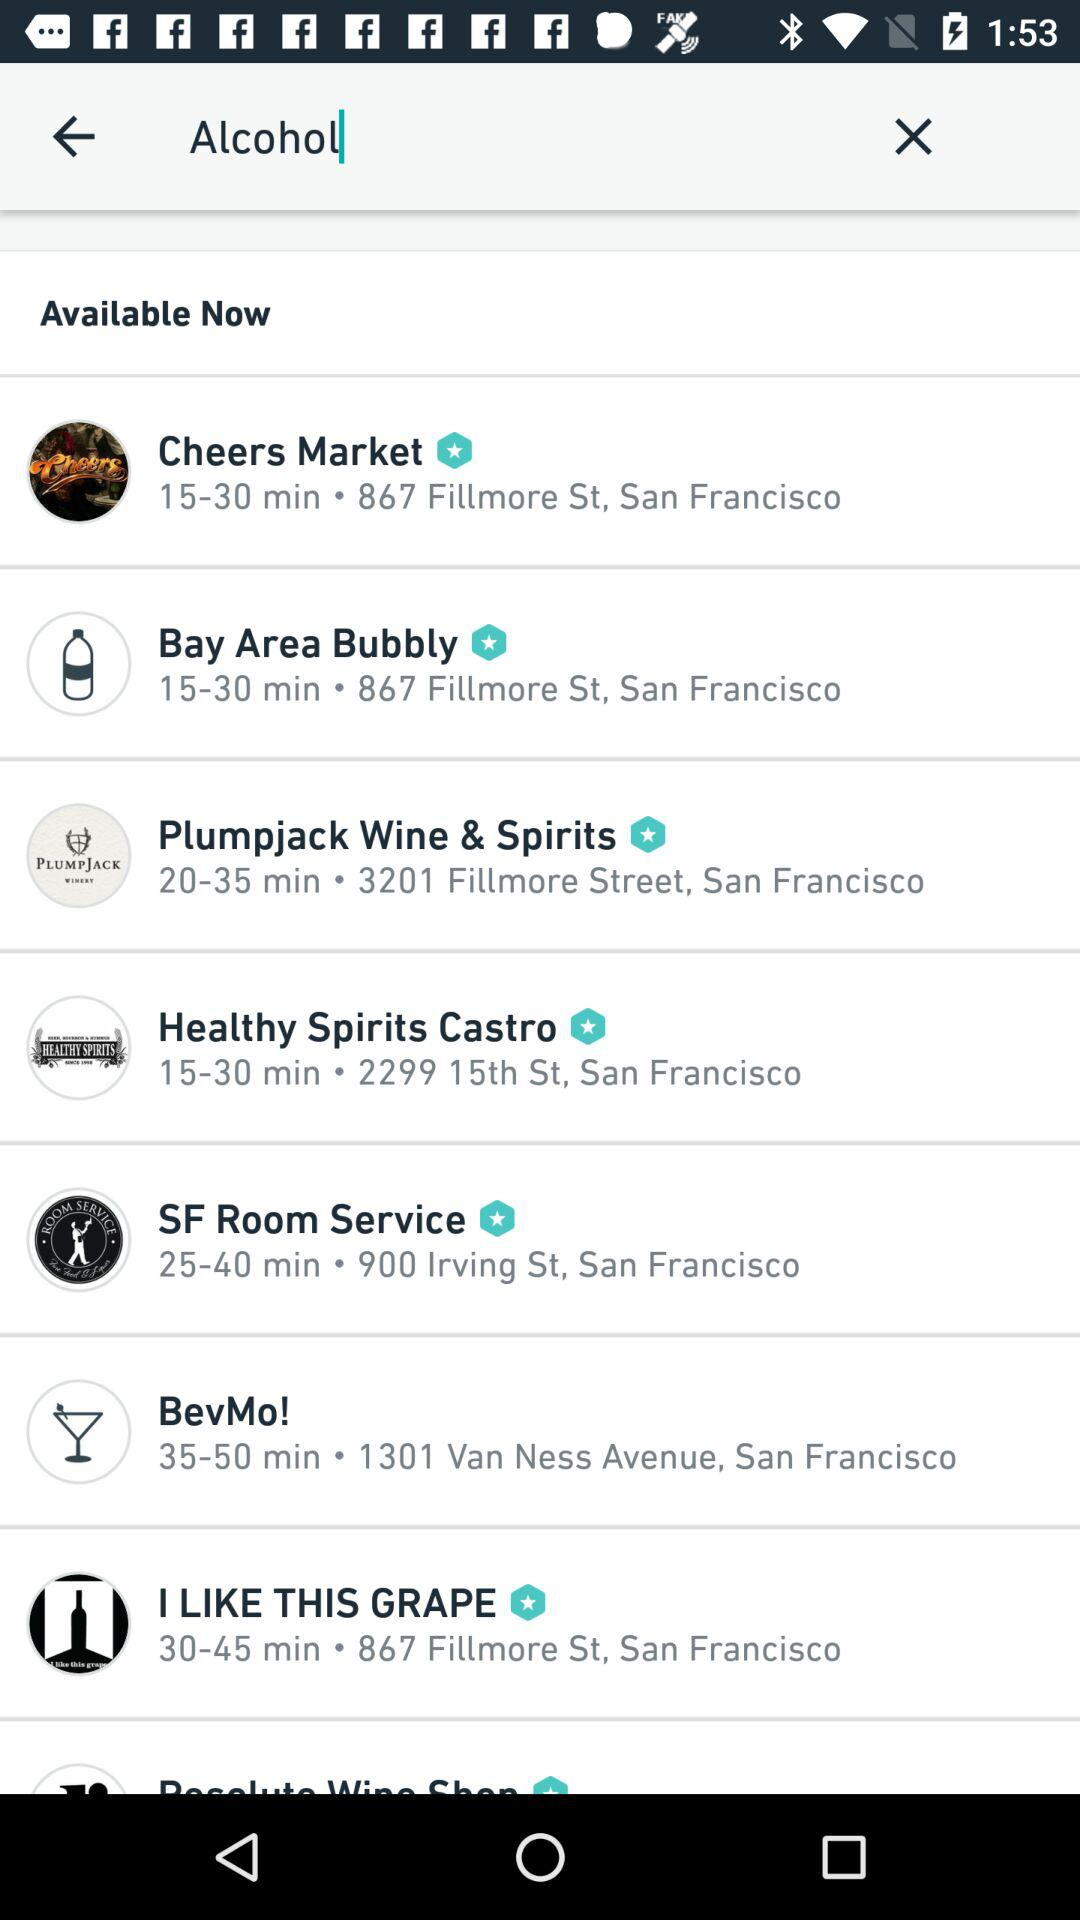Where is "BevMo!" located? "BevMo!" is located at 1301 Van Ness Avenue, San Francisco. 